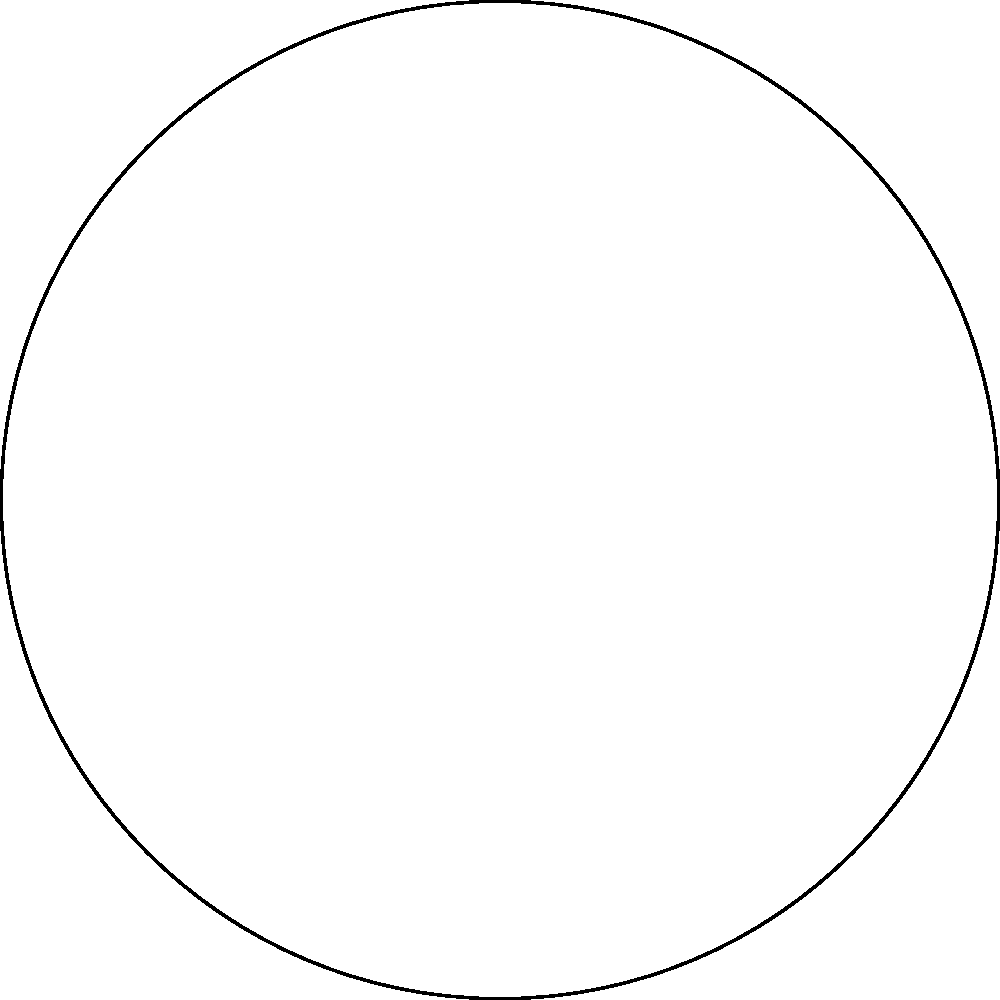In your latest art piece, you've incorporated a circular design representing the cycle of seasons. The full circle symbolizes a complete year, while a sector represents the Wet season. If the central angle of the Wet season sector is 120°, what fraction of the year does the Wet season occupy? Let's approach this step-by-step:

1) The area of a circular sector is proportional to its central angle. The ratio of the sector's area to the circle's area is equal to the ratio of the central angle to 360°.

2) Let's define:
   $A_s$ = Area of the sector
   $A_c$ = Area of the circle
   $\theta$ = Central angle of the sector in degrees

3) The relationship can be expressed as:
   $$\frac{A_s}{A_c} = \frac{\theta}{360°}$$

4) We're given that $\theta = 120°$. Let's substitute this:
   $$\frac{A_s}{A_c} = \frac{120°}{360°}$$

5) Simplify the fraction:
   $$\frac{A_s}{A_c} = \frac{1}{3}$$

6) This means the sector (representing the Wet season) occupies 1/3 of the total circle area.

7) Since the full circle represents a year, the Wet season occupies 1/3 of the year.
Answer: $\frac{1}{3}$ 